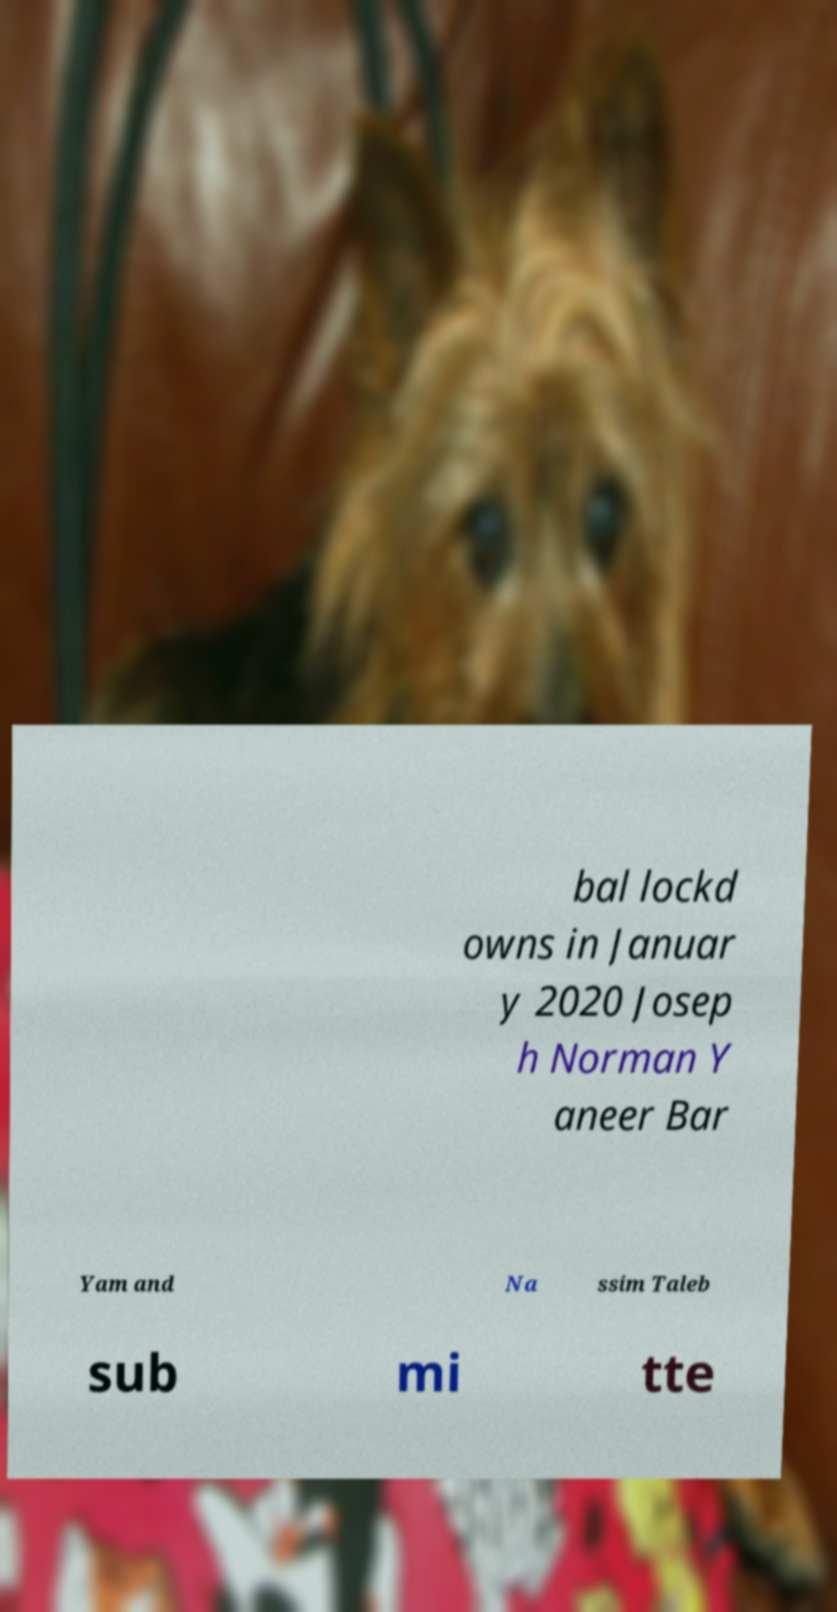Could you assist in decoding the text presented in this image and type it out clearly? bal lockd owns in Januar y 2020 Josep h Norman Y aneer Bar Yam and Na ssim Taleb sub mi tte 